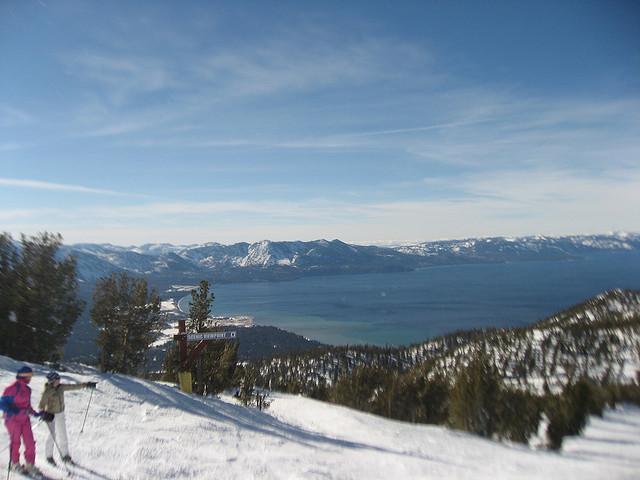What are the two people doing?
Short answer required. Skiing. What type of clouds are here?
Short answer required. Cirrus. Are they pointing at something?
Short answer required. Yes. What is in the picture?
Give a very brief answer. People skiing. 